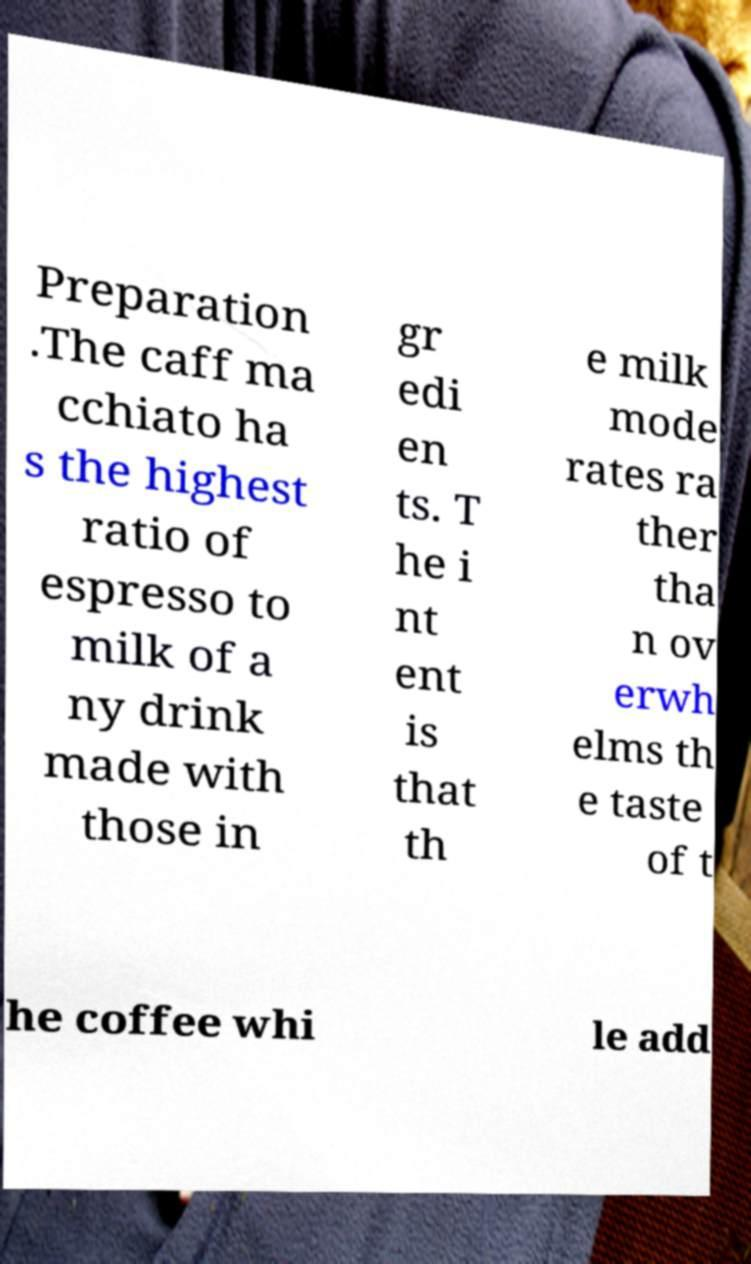There's text embedded in this image that I need extracted. Can you transcribe it verbatim? Preparation .The caff ma cchiato ha s the highest ratio of espresso to milk of a ny drink made with those in gr edi en ts. T he i nt ent is that th e milk mode rates ra ther tha n ov erwh elms th e taste of t he coffee whi le add 